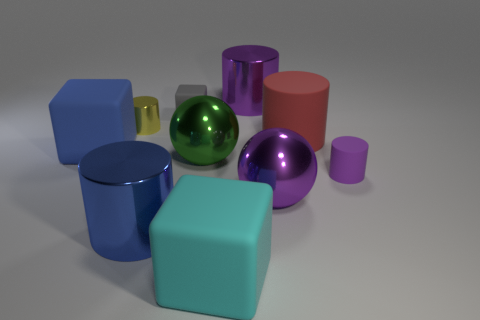Is the color of the tiny rubber cylinder the same as the cylinder behind the small yellow metallic thing?
Offer a terse response. Yes. There is another ball that is the same size as the purple sphere; what is its material?
Provide a short and direct response. Metal. Is the number of tiny gray matte objects that are in front of the blue matte block less than the number of rubber objects that are behind the purple sphere?
Your response must be concise. Yes. There is a small matte thing on the right side of the shiny cylinder behind the tiny yellow thing; what is its shape?
Give a very brief answer. Cylinder. Are there any large yellow rubber cubes?
Your answer should be compact. No. There is a tiny cylinder on the left side of the tiny gray thing; what is its color?
Your answer should be very brief. Yellow. There is a small gray rubber object; are there any cyan objects on the left side of it?
Keep it short and to the point. No. Are there more small cylinders than yellow matte spheres?
Offer a very short reply. Yes. There is a tiny cylinder to the right of the purple thing behind the large object on the left side of the yellow shiny cylinder; what color is it?
Make the answer very short. Purple. The tiny cylinder that is made of the same material as the large red cylinder is what color?
Offer a very short reply. Purple. 